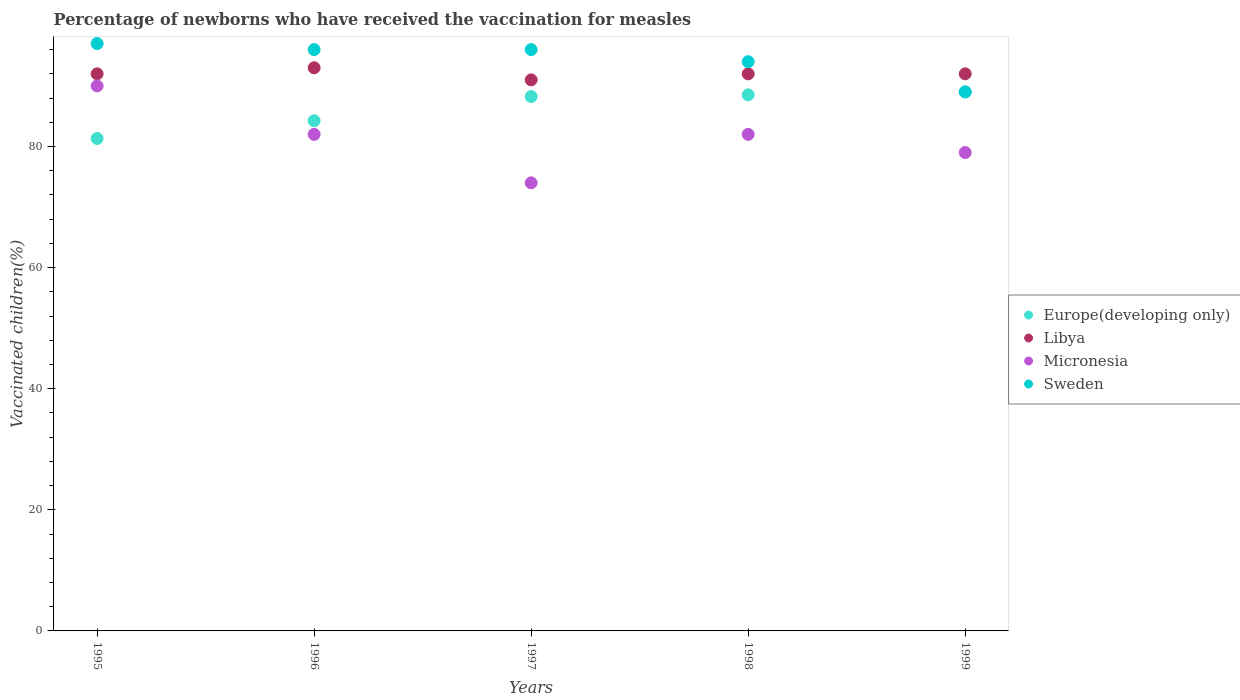How many different coloured dotlines are there?
Give a very brief answer. 4. Is the number of dotlines equal to the number of legend labels?
Ensure brevity in your answer.  Yes. What is the percentage of vaccinated children in Europe(developing only) in 1995?
Offer a very short reply. 81.32. Across all years, what is the maximum percentage of vaccinated children in Europe(developing only)?
Ensure brevity in your answer.  89.03. Across all years, what is the minimum percentage of vaccinated children in Europe(developing only)?
Your answer should be compact. 81.32. In which year was the percentage of vaccinated children in Europe(developing only) minimum?
Make the answer very short. 1995. What is the total percentage of vaccinated children in Micronesia in the graph?
Provide a short and direct response. 407. What is the difference between the percentage of vaccinated children in Libya in 1996 and that in 1999?
Your response must be concise. 1. What is the difference between the percentage of vaccinated children in Libya in 1998 and the percentage of vaccinated children in Sweden in 1996?
Ensure brevity in your answer.  -4. What is the average percentage of vaccinated children in Sweden per year?
Give a very brief answer. 94.4. In the year 1997, what is the difference between the percentage of vaccinated children in Europe(developing only) and percentage of vaccinated children in Libya?
Offer a very short reply. -2.75. In how many years, is the percentage of vaccinated children in Micronesia greater than 68 %?
Make the answer very short. 5. What is the ratio of the percentage of vaccinated children in Europe(developing only) in 1995 to that in 1998?
Give a very brief answer. 0.92. Is the difference between the percentage of vaccinated children in Europe(developing only) in 1995 and 1999 greater than the difference between the percentage of vaccinated children in Libya in 1995 and 1999?
Make the answer very short. No. What is the difference between the highest and the lowest percentage of vaccinated children in Europe(developing only)?
Provide a short and direct response. 7.71. Is it the case that in every year, the sum of the percentage of vaccinated children in Sweden and percentage of vaccinated children in Europe(developing only)  is greater than the sum of percentage of vaccinated children in Libya and percentage of vaccinated children in Micronesia?
Make the answer very short. No. Is the percentage of vaccinated children in Sweden strictly greater than the percentage of vaccinated children in Europe(developing only) over the years?
Make the answer very short. No. Is the percentage of vaccinated children in Libya strictly less than the percentage of vaccinated children in Sweden over the years?
Offer a very short reply. No. Does the graph contain any zero values?
Keep it short and to the point. No. Does the graph contain grids?
Offer a very short reply. No. How many legend labels are there?
Your answer should be very brief. 4. What is the title of the graph?
Ensure brevity in your answer.  Percentage of newborns who have received the vaccination for measles. Does "Guam" appear as one of the legend labels in the graph?
Ensure brevity in your answer.  No. What is the label or title of the Y-axis?
Provide a succinct answer. Vaccinated children(%). What is the Vaccinated children(%) in Europe(developing only) in 1995?
Offer a very short reply. 81.32. What is the Vaccinated children(%) of Libya in 1995?
Keep it short and to the point. 92. What is the Vaccinated children(%) in Micronesia in 1995?
Make the answer very short. 90. What is the Vaccinated children(%) of Sweden in 1995?
Your answer should be compact. 97. What is the Vaccinated children(%) in Europe(developing only) in 1996?
Make the answer very short. 84.25. What is the Vaccinated children(%) of Libya in 1996?
Your response must be concise. 93. What is the Vaccinated children(%) of Micronesia in 1996?
Ensure brevity in your answer.  82. What is the Vaccinated children(%) of Sweden in 1996?
Provide a short and direct response. 96. What is the Vaccinated children(%) of Europe(developing only) in 1997?
Offer a terse response. 88.25. What is the Vaccinated children(%) of Libya in 1997?
Offer a very short reply. 91. What is the Vaccinated children(%) of Micronesia in 1997?
Give a very brief answer. 74. What is the Vaccinated children(%) of Sweden in 1997?
Offer a terse response. 96. What is the Vaccinated children(%) in Europe(developing only) in 1998?
Your answer should be compact. 88.53. What is the Vaccinated children(%) of Libya in 1998?
Offer a terse response. 92. What is the Vaccinated children(%) of Sweden in 1998?
Provide a succinct answer. 94. What is the Vaccinated children(%) of Europe(developing only) in 1999?
Your response must be concise. 89.03. What is the Vaccinated children(%) in Libya in 1999?
Your answer should be very brief. 92. What is the Vaccinated children(%) in Micronesia in 1999?
Provide a short and direct response. 79. What is the Vaccinated children(%) of Sweden in 1999?
Provide a short and direct response. 89. Across all years, what is the maximum Vaccinated children(%) of Europe(developing only)?
Your response must be concise. 89.03. Across all years, what is the maximum Vaccinated children(%) in Libya?
Offer a terse response. 93. Across all years, what is the maximum Vaccinated children(%) of Sweden?
Offer a terse response. 97. Across all years, what is the minimum Vaccinated children(%) in Europe(developing only)?
Your answer should be very brief. 81.32. Across all years, what is the minimum Vaccinated children(%) of Libya?
Offer a very short reply. 91. Across all years, what is the minimum Vaccinated children(%) in Micronesia?
Give a very brief answer. 74. Across all years, what is the minimum Vaccinated children(%) of Sweden?
Offer a terse response. 89. What is the total Vaccinated children(%) of Europe(developing only) in the graph?
Your answer should be very brief. 431.37. What is the total Vaccinated children(%) of Libya in the graph?
Provide a short and direct response. 460. What is the total Vaccinated children(%) in Micronesia in the graph?
Your answer should be very brief. 407. What is the total Vaccinated children(%) of Sweden in the graph?
Your answer should be very brief. 472. What is the difference between the Vaccinated children(%) in Europe(developing only) in 1995 and that in 1996?
Give a very brief answer. -2.93. What is the difference between the Vaccinated children(%) in Sweden in 1995 and that in 1996?
Ensure brevity in your answer.  1. What is the difference between the Vaccinated children(%) in Europe(developing only) in 1995 and that in 1997?
Offer a very short reply. -6.92. What is the difference between the Vaccinated children(%) in Libya in 1995 and that in 1997?
Offer a terse response. 1. What is the difference between the Vaccinated children(%) in Europe(developing only) in 1995 and that in 1998?
Make the answer very short. -7.2. What is the difference between the Vaccinated children(%) in Micronesia in 1995 and that in 1998?
Make the answer very short. 8. What is the difference between the Vaccinated children(%) in Europe(developing only) in 1995 and that in 1999?
Provide a succinct answer. -7.71. What is the difference between the Vaccinated children(%) of Libya in 1995 and that in 1999?
Provide a succinct answer. 0. What is the difference between the Vaccinated children(%) of Micronesia in 1995 and that in 1999?
Keep it short and to the point. 11. What is the difference between the Vaccinated children(%) of Europe(developing only) in 1996 and that in 1997?
Provide a short and direct response. -4. What is the difference between the Vaccinated children(%) of Micronesia in 1996 and that in 1997?
Offer a very short reply. 8. What is the difference between the Vaccinated children(%) in Europe(developing only) in 1996 and that in 1998?
Offer a very short reply. -4.28. What is the difference between the Vaccinated children(%) in Libya in 1996 and that in 1998?
Offer a terse response. 1. What is the difference between the Vaccinated children(%) of Sweden in 1996 and that in 1998?
Your answer should be very brief. 2. What is the difference between the Vaccinated children(%) of Europe(developing only) in 1996 and that in 1999?
Ensure brevity in your answer.  -4.78. What is the difference between the Vaccinated children(%) in Europe(developing only) in 1997 and that in 1998?
Make the answer very short. -0.28. What is the difference between the Vaccinated children(%) in Micronesia in 1997 and that in 1998?
Provide a succinct answer. -8. What is the difference between the Vaccinated children(%) of Sweden in 1997 and that in 1998?
Your answer should be compact. 2. What is the difference between the Vaccinated children(%) in Europe(developing only) in 1997 and that in 1999?
Provide a succinct answer. -0.78. What is the difference between the Vaccinated children(%) in Micronesia in 1997 and that in 1999?
Your answer should be very brief. -5. What is the difference between the Vaccinated children(%) of Europe(developing only) in 1998 and that in 1999?
Offer a very short reply. -0.5. What is the difference between the Vaccinated children(%) in Libya in 1998 and that in 1999?
Your answer should be compact. 0. What is the difference between the Vaccinated children(%) in Europe(developing only) in 1995 and the Vaccinated children(%) in Libya in 1996?
Your response must be concise. -11.68. What is the difference between the Vaccinated children(%) of Europe(developing only) in 1995 and the Vaccinated children(%) of Micronesia in 1996?
Your response must be concise. -0.68. What is the difference between the Vaccinated children(%) of Europe(developing only) in 1995 and the Vaccinated children(%) of Sweden in 1996?
Provide a succinct answer. -14.68. What is the difference between the Vaccinated children(%) in Libya in 1995 and the Vaccinated children(%) in Sweden in 1996?
Keep it short and to the point. -4. What is the difference between the Vaccinated children(%) of Europe(developing only) in 1995 and the Vaccinated children(%) of Libya in 1997?
Give a very brief answer. -9.68. What is the difference between the Vaccinated children(%) in Europe(developing only) in 1995 and the Vaccinated children(%) in Micronesia in 1997?
Your response must be concise. 7.32. What is the difference between the Vaccinated children(%) of Europe(developing only) in 1995 and the Vaccinated children(%) of Sweden in 1997?
Your answer should be compact. -14.68. What is the difference between the Vaccinated children(%) of Libya in 1995 and the Vaccinated children(%) of Sweden in 1997?
Your answer should be very brief. -4. What is the difference between the Vaccinated children(%) in Micronesia in 1995 and the Vaccinated children(%) in Sweden in 1997?
Give a very brief answer. -6. What is the difference between the Vaccinated children(%) in Europe(developing only) in 1995 and the Vaccinated children(%) in Libya in 1998?
Give a very brief answer. -10.68. What is the difference between the Vaccinated children(%) in Europe(developing only) in 1995 and the Vaccinated children(%) in Micronesia in 1998?
Offer a terse response. -0.68. What is the difference between the Vaccinated children(%) in Europe(developing only) in 1995 and the Vaccinated children(%) in Sweden in 1998?
Give a very brief answer. -12.68. What is the difference between the Vaccinated children(%) in Libya in 1995 and the Vaccinated children(%) in Micronesia in 1998?
Provide a short and direct response. 10. What is the difference between the Vaccinated children(%) of Libya in 1995 and the Vaccinated children(%) of Sweden in 1998?
Make the answer very short. -2. What is the difference between the Vaccinated children(%) in Europe(developing only) in 1995 and the Vaccinated children(%) in Libya in 1999?
Your response must be concise. -10.68. What is the difference between the Vaccinated children(%) of Europe(developing only) in 1995 and the Vaccinated children(%) of Micronesia in 1999?
Offer a very short reply. 2.32. What is the difference between the Vaccinated children(%) in Europe(developing only) in 1995 and the Vaccinated children(%) in Sweden in 1999?
Your answer should be very brief. -7.68. What is the difference between the Vaccinated children(%) of Libya in 1995 and the Vaccinated children(%) of Micronesia in 1999?
Provide a succinct answer. 13. What is the difference between the Vaccinated children(%) of Libya in 1995 and the Vaccinated children(%) of Sweden in 1999?
Ensure brevity in your answer.  3. What is the difference between the Vaccinated children(%) in Europe(developing only) in 1996 and the Vaccinated children(%) in Libya in 1997?
Offer a very short reply. -6.75. What is the difference between the Vaccinated children(%) of Europe(developing only) in 1996 and the Vaccinated children(%) of Micronesia in 1997?
Give a very brief answer. 10.25. What is the difference between the Vaccinated children(%) in Europe(developing only) in 1996 and the Vaccinated children(%) in Sweden in 1997?
Provide a succinct answer. -11.75. What is the difference between the Vaccinated children(%) of Europe(developing only) in 1996 and the Vaccinated children(%) of Libya in 1998?
Offer a terse response. -7.75. What is the difference between the Vaccinated children(%) in Europe(developing only) in 1996 and the Vaccinated children(%) in Micronesia in 1998?
Give a very brief answer. 2.25. What is the difference between the Vaccinated children(%) of Europe(developing only) in 1996 and the Vaccinated children(%) of Sweden in 1998?
Give a very brief answer. -9.75. What is the difference between the Vaccinated children(%) in Libya in 1996 and the Vaccinated children(%) in Micronesia in 1998?
Give a very brief answer. 11. What is the difference between the Vaccinated children(%) of Micronesia in 1996 and the Vaccinated children(%) of Sweden in 1998?
Give a very brief answer. -12. What is the difference between the Vaccinated children(%) in Europe(developing only) in 1996 and the Vaccinated children(%) in Libya in 1999?
Keep it short and to the point. -7.75. What is the difference between the Vaccinated children(%) in Europe(developing only) in 1996 and the Vaccinated children(%) in Micronesia in 1999?
Keep it short and to the point. 5.25. What is the difference between the Vaccinated children(%) in Europe(developing only) in 1996 and the Vaccinated children(%) in Sweden in 1999?
Your answer should be very brief. -4.75. What is the difference between the Vaccinated children(%) of Micronesia in 1996 and the Vaccinated children(%) of Sweden in 1999?
Your answer should be compact. -7. What is the difference between the Vaccinated children(%) in Europe(developing only) in 1997 and the Vaccinated children(%) in Libya in 1998?
Your response must be concise. -3.75. What is the difference between the Vaccinated children(%) in Europe(developing only) in 1997 and the Vaccinated children(%) in Micronesia in 1998?
Provide a succinct answer. 6.25. What is the difference between the Vaccinated children(%) in Europe(developing only) in 1997 and the Vaccinated children(%) in Sweden in 1998?
Provide a succinct answer. -5.75. What is the difference between the Vaccinated children(%) of Libya in 1997 and the Vaccinated children(%) of Micronesia in 1998?
Provide a short and direct response. 9. What is the difference between the Vaccinated children(%) in Micronesia in 1997 and the Vaccinated children(%) in Sweden in 1998?
Provide a succinct answer. -20. What is the difference between the Vaccinated children(%) in Europe(developing only) in 1997 and the Vaccinated children(%) in Libya in 1999?
Give a very brief answer. -3.75. What is the difference between the Vaccinated children(%) of Europe(developing only) in 1997 and the Vaccinated children(%) of Micronesia in 1999?
Make the answer very short. 9.25. What is the difference between the Vaccinated children(%) in Europe(developing only) in 1997 and the Vaccinated children(%) in Sweden in 1999?
Provide a succinct answer. -0.75. What is the difference between the Vaccinated children(%) of Micronesia in 1997 and the Vaccinated children(%) of Sweden in 1999?
Make the answer very short. -15. What is the difference between the Vaccinated children(%) of Europe(developing only) in 1998 and the Vaccinated children(%) of Libya in 1999?
Give a very brief answer. -3.48. What is the difference between the Vaccinated children(%) in Europe(developing only) in 1998 and the Vaccinated children(%) in Micronesia in 1999?
Offer a very short reply. 9.53. What is the difference between the Vaccinated children(%) of Europe(developing only) in 1998 and the Vaccinated children(%) of Sweden in 1999?
Give a very brief answer. -0.47. What is the difference between the Vaccinated children(%) in Libya in 1998 and the Vaccinated children(%) in Micronesia in 1999?
Your answer should be compact. 13. What is the difference between the Vaccinated children(%) of Micronesia in 1998 and the Vaccinated children(%) of Sweden in 1999?
Your answer should be very brief. -7. What is the average Vaccinated children(%) in Europe(developing only) per year?
Ensure brevity in your answer.  86.27. What is the average Vaccinated children(%) of Libya per year?
Your answer should be very brief. 92. What is the average Vaccinated children(%) in Micronesia per year?
Make the answer very short. 81.4. What is the average Vaccinated children(%) in Sweden per year?
Provide a short and direct response. 94.4. In the year 1995, what is the difference between the Vaccinated children(%) of Europe(developing only) and Vaccinated children(%) of Libya?
Your response must be concise. -10.68. In the year 1995, what is the difference between the Vaccinated children(%) of Europe(developing only) and Vaccinated children(%) of Micronesia?
Ensure brevity in your answer.  -8.68. In the year 1995, what is the difference between the Vaccinated children(%) in Europe(developing only) and Vaccinated children(%) in Sweden?
Ensure brevity in your answer.  -15.68. In the year 1995, what is the difference between the Vaccinated children(%) of Libya and Vaccinated children(%) of Micronesia?
Provide a succinct answer. 2. In the year 1996, what is the difference between the Vaccinated children(%) of Europe(developing only) and Vaccinated children(%) of Libya?
Your answer should be compact. -8.75. In the year 1996, what is the difference between the Vaccinated children(%) of Europe(developing only) and Vaccinated children(%) of Micronesia?
Your answer should be compact. 2.25. In the year 1996, what is the difference between the Vaccinated children(%) in Europe(developing only) and Vaccinated children(%) in Sweden?
Your response must be concise. -11.75. In the year 1996, what is the difference between the Vaccinated children(%) of Micronesia and Vaccinated children(%) of Sweden?
Offer a very short reply. -14. In the year 1997, what is the difference between the Vaccinated children(%) in Europe(developing only) and Vaccinated children(%) in Libya?
Make the answer very short. -2.75. In the year 1997, what is the difference between the Vaccinated children(%) in Europe(developing only) and Vaccinated children(%) in Micronesia?
Provide a succinct answer. 14.25. In the year 1997, what is the difference between the Vaccinated children(%) of Europe(developing only) and Vaccinated children(%) of Sweden?
Your answer should be very brief. -7.75. In the year 1997, what is the difference between the Vaccinated children(%) of Libya and Vaccinated children(%) of Micronesia?
Give a very brief answer. 17. In the year 1998, what is the difference between the Vaccinated children(%) of Europe(developing only) and Vaccinated children(%) of Libya?
Keep it short and to the point. -3.48. In the year 1998, what is the difference between the Vaccinated children(%) in Europe(developing only) and Vaccinated children(%) in Micronesia?
Give a very brief answer. 6.53. In the year 1998, what is the difference between the Vaccinated children(%) of Europe(developing only) and Vaccinated children(%) of Sweden?
Provide a succinct answer. -5.47. In the year 1998, what is the difference between the Vaccinated children(%) of Libya and Vaccinated children(%) of Sweden?
Offer a terse response. -2. In the year 1999, what is the difference between the Vaccinated children(%) of Europe(developing only) and Vaccinated children(%) of Libya?
Your answer should be very brief. -2.97. In the year 1999, what is the difference between the Vaccinated children(%) of Europe(developing only) and Vaccinated children(%) of Micronesia?
Offer a terse response. 10.03. In the year 1999, what is the difference between the Vaccinated children(%) of Europe(developing only) and Vaccinated children(%) of Sweden?
Your answer should be compact. 0.03. In the year 1999, what is the difference between the Vaccinated children(%) in Libya and Vaccinated children(%) in Micronesia?
Your answer should be very brief. 13. In the year 1999, what is the difference between the Vaccinated children(%) of Micronesia and Vaccinated children(%) of Sweden?
Give a very brief answer. -10. What is the ratio of the Vaccinated children(%) in Europe(developing only) in 1995 to that in 1996?
Offer a terse response. 0.97. What is the ratio of the Vaccinated children(%) in Micronesia in 1995 to that in 1996?
Keep it short and to the point. 1.1. What is the ratio of the Vaccinated children(%) in Sweden in 1995 to that in 1996?
Your response must be concise. 1.01. What is the ratio of the Vaccinated children(%) in Europe(developing only) in 1995 to that in 1997?
Offer a terse response. 0.92. What is the ratio of the Vaccinated children(%) in Micronesia in 1995 to that in 1997?
Offer a terse response. 1.22. What is the ratio of the Vaccinated children(%) in Sweden in 1995 to that in 1997?
Make the answer very short. 1.01. What is the ratio of the Vaccinated children(%) in Europe(developing only) in 1995 to that in 1998?
Keep it short and to the point. 0.92. What is the ratio of the Vaccinated children(%) of Libya in 1995 to that in 1998?
Provide a succinct answer. 1. What is the ratio of the Vaccinated children(%) in Micronesia in 1995 to that in 1998?
Your response must be concise. 1.1. What is the ratio of the Vaccinated children(%) in Sweden in 1995 to that in 1998?
Provide a short and direct response. 1.03. What is the ratio of the Vaccinated children(%) in Europe(developing only) in 1995 to that in 1999?
Provide a short and direct response. 0.91. What is the ratio of the Vaccinated children(%) in Libya in 1995 to that in 1999?
Provide a short and direct response. 1. What is the ratio of the Vaccinated children(%) in Micronesia in 1995 to that in 1999?
Provide a short and direct response. 1.14. What is the ratio of the Vaccinated children(%) of Sweden in 1995 to that in 1999?
Provide a succinct answer. 1.09. What is the ratio of the Vaccinated children(%) in Europe(developing only) in 1996 to that in 1997?
Provide a short and direct response. 0.95. What is the ratio of the Vaccinated children(%) in Micronesia in 1996 to that in 1997?
Your response must be concise. 1.11. What is the ratio of the Vaccinated children(%) in Sweden in 1996 to that in 1997?
Your answer should be compact. 1. What is the ratio of the Vaccinated children(%) in Europe(developing only) in 1996 to that in 1998?
Keep it short and to the point. 0.95. What is the ratio of the Vaccinated children(%) of Libya in 1996 to that in 1998?
Give a very brief answer. 1.01. What is the ratio of the Vaccinated children(%) of Sweden in 1996 to that in 1998?
Offer a very short reply. 1.02. What is the ratio of the Vaccinated children(%) of Europe(developing only) in 1996 to that in 1999?
Offer a terse response. 0.95. What is the ratio of the Vaccinated children(%) of Libya in 1996 to that in 1999?
Provide a succinct answer. 1.01. What is the ratio of the Vaccinated children(%) of Micronesia in 1996 to that in 1999?
Ensure brevity in your answer.  1.04. What is the ratio of the Vaccinated children(%) in Sweden in 1996 to that in 1999?
Give a very brief answer. 1.08. What is the ratio of the Vaccinated children(%) in Libya in 1997 to that in 1998?
Offer a terse response. 0.99. What is the ratio of the Vaccinated children(%) in Micronesia in 1997 to that in 1998?
Your answer should be very brief. 0.9. What is the ratio of the Vaccinated children(%) in Sweden in 1997 to that in 1998?
Ensure brevity in your answer.  1.02. What is the ratio of the Vaccinated children(%) in Europe(developing only) in 1997 to that in 1999?
Your response must be concise. 0.99. What is the ratio of the Vaccinated children(%) of Libya in 1997 to that in 1999?
Keep it short and to the point. 0.99. What is the ratio of the Vaccinated children(%) of Micronesia in 1997 to that in 1999?
Offer a very short reply. 0.94. What is the ratio of the Vaccinated children(%) in Sweden in 1997 to that in 1999?
Offer a terse response. 1.08. What is the ratio of the Vaccinated children(%) in Europe(developing only) in 1998 to that in 1999?
Offer a very short reply. 0.99. What is the ratio of the Vaccinated children(%) of Micronesia in 1998 to that in 1999?
Your response must be concise. 1.04. What is the ratio of the Vaccinated children(%) of Sweden in 1998 to that in 1999?
Your response must be concise. 1.06. What is the difference between the highest and the second highest Vaccinated children(%) in Europe(developing only)?
Offer a terse response. 0.5. What is the difference between the highest and the second highest Vaccinated children(%) of Sweden?
Give a very brief answer. 1. What is the difference between the highest and the lowest Vaccinated children(%) in Europe(developing only)?
Your response must be concise. 7.71. What is the difference between the highest and the lowest Vaccinated children(%) of Sweden?
Make the answer very short. 8. 